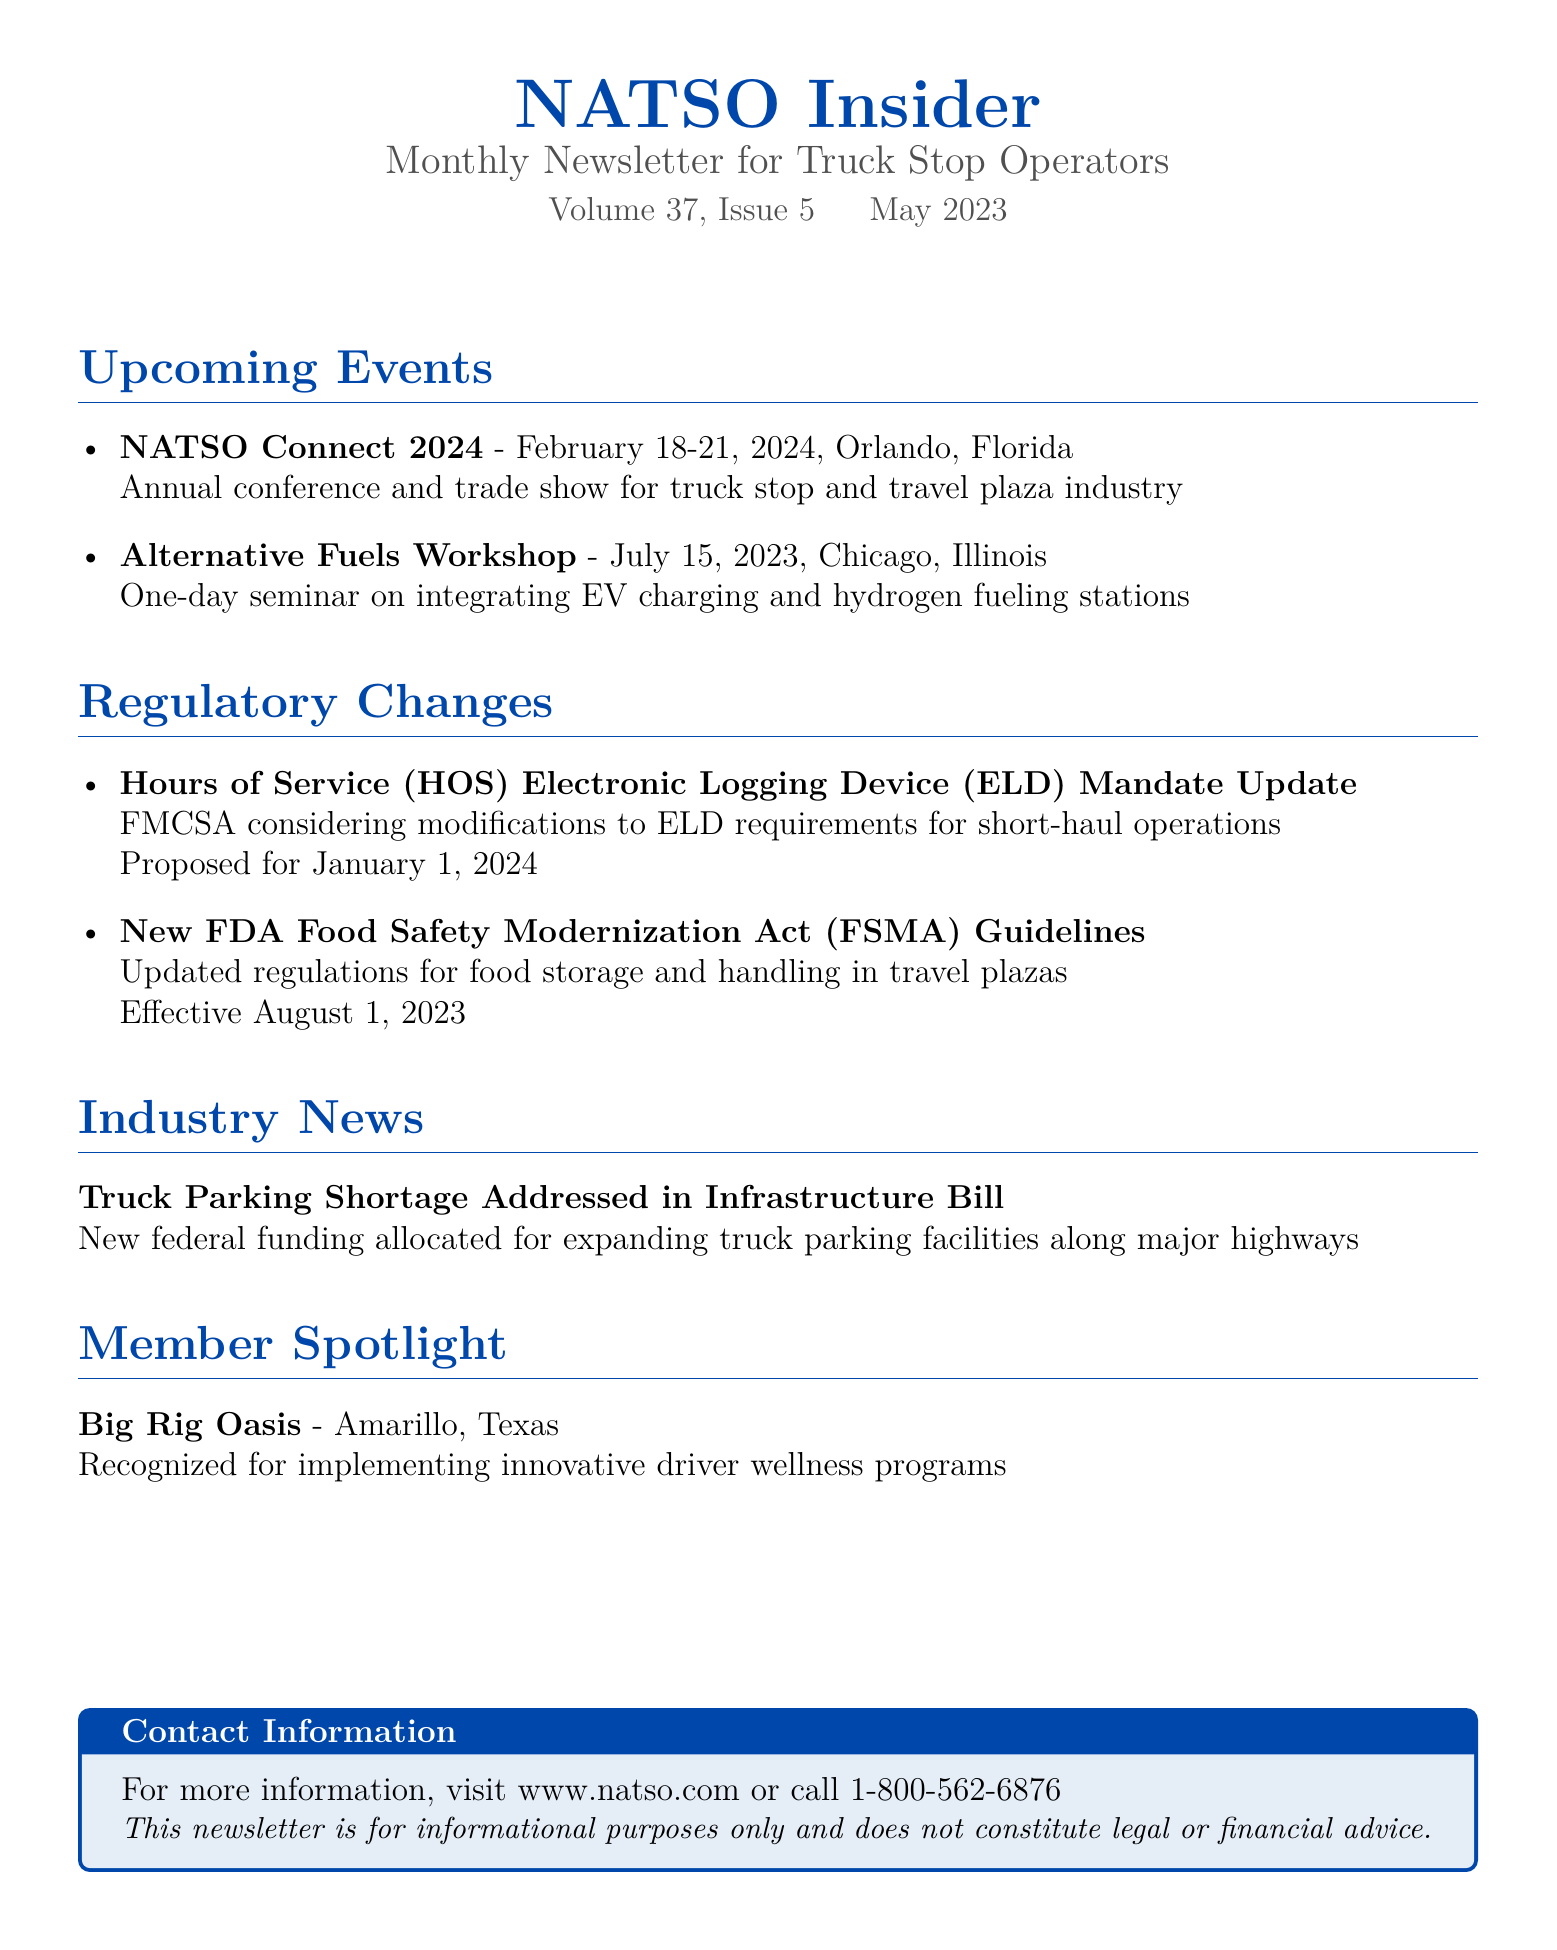What are the dates for NATSO Connect 2024? The event is scheduled from February 18-21, 2024, in Orlando, Florida.
Answer: February 18-21, 2024 What is the location of the Alternative Fuels Workshop? The workshop is being held in Chicago, Illinois.
Answer: Chicago, Illinois What regulatory change is proposed for January 1, 2024? An update regarding modifications to ELD requirements for short-haul operations is proposed.
Answer: ELD requirements update When do the new FSMA guidelines become effective? The updated regulations for food storage and handling take effect on August 1, 2023.
Answer: August 1, 2023 Which truck stop is recognized in the Member Spotlight? The Member Spotlight features Big Rig Oasis located in Amarillo, Texas.
Answer: Big Rig Oasis What federal issue is addressed in the industry news? The newsletter discusses the truck parking shortage addressed in an infrastructure bill.
Answer: Truck parking shortage What type of event is NATSO Connect 2024? It is an annual conference and trade show for the truck stop and travel plaza industry.
Answer: Annual conference and trade show What unique programs did Big Rig Oasis implement? Big Rig Oasis is recognized for its innovative driver wellness programs.
Answer: Driver wellness programs 